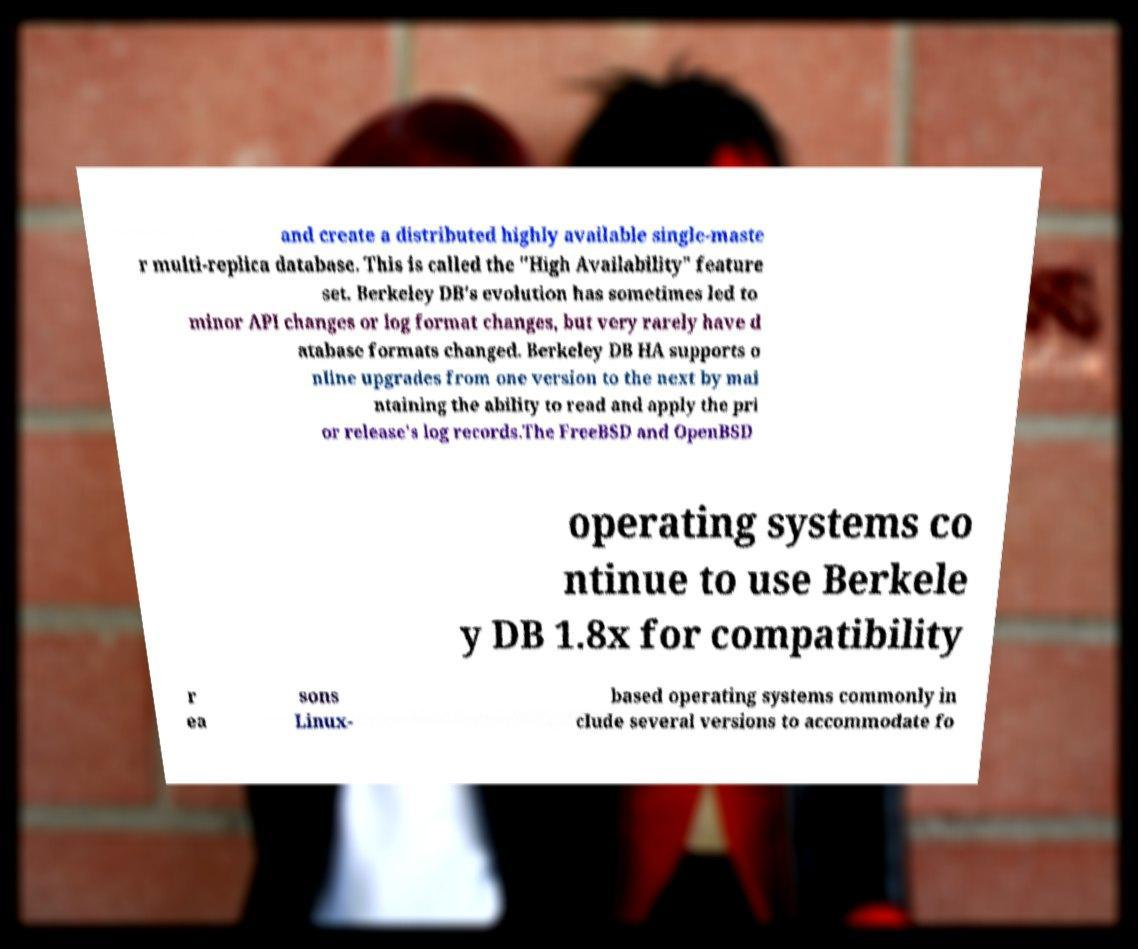Can you read and provide the text displayed in the image?This photo seems to have some interesting text. Can you extract and type it out for me? and create a distributed highly available single-maste r multi-replica database. This is called the "High Availability" feature set. Berkeley DB's evolution has sometimes led to minor API changes or log format changes, but very rarely have d atabase formats changed. Berkeley DB HA supports o nline upgrades from one version to the next by mai ntaining the ability to read and apply the pri or release's log records.The FreeBSD and OpenBSD operating systems co ntinue to use Berkele y DB 1.8x for compatibility r ea sons Linux- based operating systems commonly in clude several versions to accommodate fo 